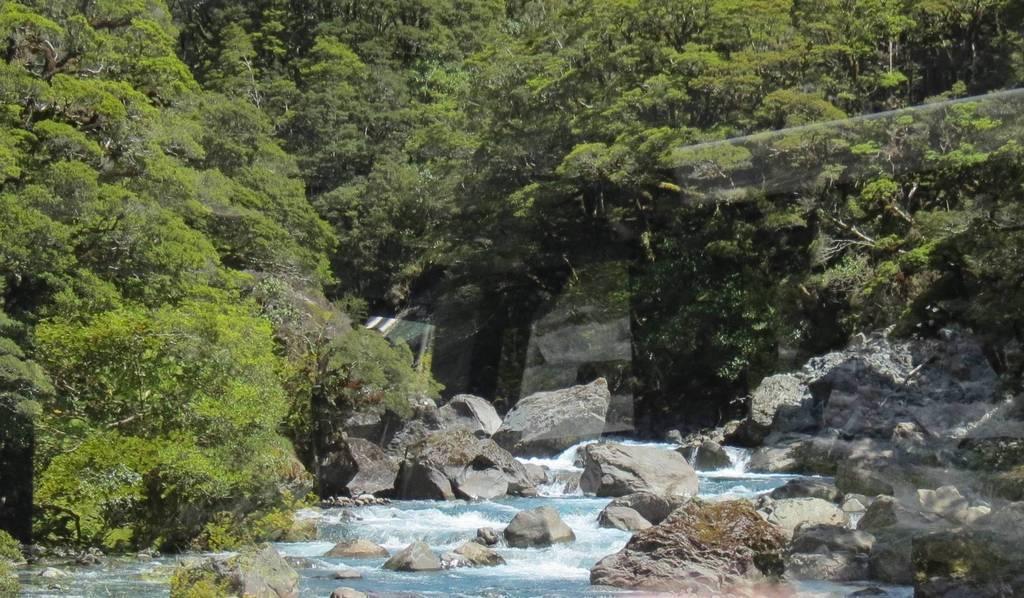Can you describe this image briefly? In this picture we can see water, few rocks and trees. 